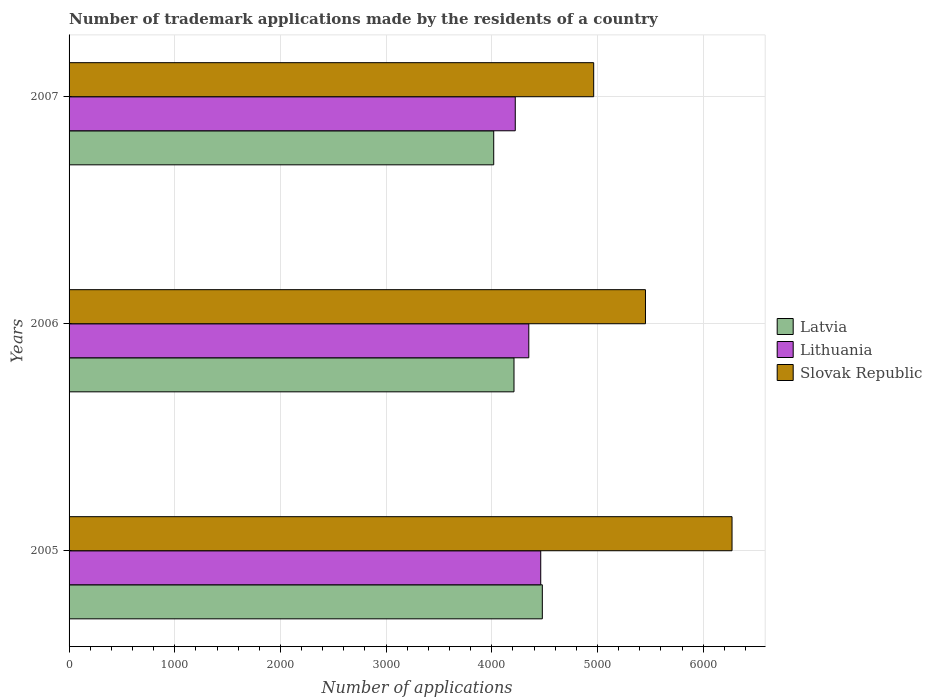Are the number of bars per tick equal to the number of legend labels?
Offer a terse response. Yes. How many bars are there on the 2nd tick from the bottom?
Provide a short and direct response. 3. What is the label of the 2nd group of bars from the top?
Offer a terse response. 2006. In how many cases, is the number of bars for a given year not equal to the number of legend labels?
Your answer should be very brief. 0. What is the number of trademark applications made by the residents in Latvia in 2006?
Make the answer very short. 4210. Across all years, what is the maximum number of trademark applications made by the residents in Latvia?
Give a very brief answer. 4478. Across all years, what is the minimum number of trademark applications made by the residents in Latvia?
Keep it short and to the point. 4018. What is the total number of trademark applications made by the residents in Lithuania in the graph?
Provide a short and direct response. 1.30e+04. What is the difference between the number of trademark applications made by the residents in Slovak Republic in 2005 and that in 2006?
Provide a short and direct response. 819. What is the difference between the number of trademark applications made by the residents in Slovak Republic in 2005 and the number of trademark applications made by the residents in Latvia in 2007?
Keep it short and to the point. 2255. What is the average number of trademark applications made by the residents in Lithuania per year?
Your answer should be compact. 4345. In the year 2005, what is the difference between the number of trademark applications made by the residents in Lithuania and number of trademark applications made by the residents in Slovak Republic?
Ensure brevity in your answer.  -1810. What is the ratio of the number of trademark applications made by the residents in Latvia in 2005 to that in 2006?
Offer a very short reply. 1.06. Is the number of trademark applications made by the residents in Latvia in 2005 less than that in 2007?
Ensure brevity in your answer.  No. Is the difference between the number of trademark applications made by the residents in Lithuania in 2005 and 2007 greater than the difference between the number of trademark applications made by the residents in Slovak Republic in 2005 and 2007?
Offer a terse response. No. What is the difference between the highest and the second highest number of trademark applications made by the residents in Lithuania?
Offer a terse response. 113. What is the difference between the highest and the lowest number of trademark applications made by the residents in Lithuania?
Make the answer very short. 241. What does the 1st bar from the top in 2005 represents?
Offer a terse response. Slovak Republic. What does the 2nd bar from the bottom in 2005 represents?
Give a very brief answer. Lithuania. How many bars are there?
Provide a short and direct response. 9. Are all the bars in the graph horizontal?
Provide a short and direct response. Yes. What is the difference between two consecutive major ticks on the X-axis?
Your answer should be very brief. 1000. Does the graph contain any zero values?
Keep it short and to the point. No. Does the graph contain grids?
Make the answer very short. Yes. How are the legend labels stacked?
Your response must be concise. Vertical. What is the title of the graph?
Your response must be concise. Number of trademark applications made by the residents of a country. What is the label or title of the X-axis?
Your response must be concise. Number of applications. What is the label or title of the Y-axis?
Ensure brevity in your answer.  Years. What is the Number of applications of Latvia in 2005?
Offer a terse response. 4478. What is the Number of applications of Lithuania in 2005?
Your response must be concise. 4463. What is the Number of applications of Slovak Republic in 2005?
Provide a succinct answer. 6273. What is the Number of applications of Latvia in 2006?
Ensure brevity in your answer.  4210. What is the Number of applications of Lithuania in 2006?
Your answer should be very brief. 4350. What is the Number of applications in Slovak Republic in 2006?
Provide a short and direct response. 5454. What is the Number of applications in Latvia in 2007?
Ensure brevity in your answer.  4018. What is the Number of applications in Lithuania in 2007?
Ensure brevity in your answer.  4222. What is the Number of applications in Slovak Republic in 2007?
Your answer should be very brief. 4964. Across all years, what is the maximum Number of applications of Latvia?
Your answer should be compact. 4478. Across all years, what is the maximum Number of applications of Lithuania?
Keep it short and to the point. 4463. Across all years, what is the maximum Number of applications of Slovak Republic?
Your answer should be compact. 6273. Across all years, what is the minimum Number of applications of Latvia?
Offer a very short reply. 4018. Across all years, what is the minimum Number of applications in Lithuania?
Give a very brief answer. 4222. Across all years, what is the minimum Number of applications of Slovak Republic?
Give a very brief answer. 4964. What is the total Number of applications in Latvia in the graph?
Offer a very short reply. 1.27e+04. What is the total Number of applications of Lithuania in the graph?
Your answer should be very brief. 1.30e+04. What is the total Number of applications of Slovak Republic in the graph?
Make the answer very short. 1.67e+04. What is the difference between the Number of applications of Latvia in 2005 and that in 2006?
Offer a very short reply. 268. What is the difference between the Number of applications of Lithuania in 2005 and that in 2006?
Offer a very short reply. 113. What is the difference between the Number of applications in Slovak Republic in 2005 and that in 2006?
Your answer should be compact. 819. What is the difference between the Number of applications in Latvia in 2005 and that in 2007?
Make the answer very short. 460. What is the difference between the Number of applications of Lithuania in 2005 and that in 2007?
Your answer should be very brief. 241. What is the difference between the Number of applications of Slovak Republic in 2005 and that in 2007?
Your answer should be very brief. 1309. What is the difference between the Number of applications in Latvia in 2006 and that in 2007?
Your response must be concise. 192. What is the difference between the Number of applications in Lithuania in 2006 and that in 2007?
Give a very brief answer. 128. What is the difference between the Number of applications in Slovak Republic in 2006 and that in 2007?
Provide a short and direct response. 490. What is the difference between the Number of applications of Latvia in 2005 and the Number of applications of Lithuania in 2006?
Offer a terse response. 128. What is the difference between the Number of applications in Latvia in 2005 and the Number of applications in Slovak Republic in 2006?
Make the answer very short. -976. What is the difference between the Number of applications of Lithuania in 2005 and the Number of applications of Slovak Republic in 2006?
Ensure brevity in your answer.  -991. What is the difference between the Number of applications of Latvia in 2005 and the Number of applications of Lithuania in 2007?
Make the answer very short. 256. What is the difference between the Number of applications of Latvia in 2005 and the Number of applications of Slovak Republic in 2007?
Provide a short and direct response. -486. What is the difference between the Number of applications of Lithuania in 2005 and the Number of applications of Slovak Republic in 2007?
Make the answer very short. -501. What is the difference between the Number of applications in Latvia in 2006 and the Number of applications in Lithuania in 2007?
Make the answer very short. -12. What is the difference between the Number of applications of Latvia in 2006 and the Number of applications of Slovak Republic in 2007?
Keep it short and to the point. -754. What is the difference between the Number of applications in Lithuania in 2006 and the Number of applications in Slovak Republic in 2007?
Provide a succinct answer. -614. What is the average Number of applications in Latvia per year?
Make the answer very short. 4235.33. What is the average Number of applications in Lithuania per year?
Give a very brief answer. 4345. What is the average Number of applications in Slovak Republic per year?
Your response must be concise. 5563.67. In the year 2005, what is the difference between the Number of applications in Latvia and Number of applications in Lithuania?
Your response must be concise. 15. In the year 2005, what is the difference between the Number of applications of Latvia and Number of applications of Slovak Republic?
Provide a short and direct response. -1795. In the year 2005, what is the difference between the Number of applications in Lithuania and Number of applications in Slovak Republic?
Provide a short and direct response. -1810. In the year 2006, what is the difference between the Number of applications in Latvia and Number of applications in Lithuania?
Your answer should be very brief. -140. In the year 2006, what is the difference between the Number of applications of Latvia and Number of applications of Slovak Republic?
Keep it short and to the point. -1244. In the year 2006, what is the difference between the Number of applications in Lithuania and Number of applications in Slovak Republic?
Ensure brevity in your answer.  -1104. In the year 2007, what is the difference between the Number of applications in Latvia and Number of applications in Lithuania?
Your response must be concise. -204. In the year 2007, what is the difference between the Number of applications in Latvia and Number of applications in Slovak Republic?
Make the answer very short. -946. In the year 2007, what is the difference between the Number of applications of Lithuania and Number of applications of Slovak Republic?
Your answer should be very brief. -742. What is the ratio of the Number of applications in Latvia in 2005 to that in 2006?
Make the answer very short. 1.06. What is the ratio of the Number of applications in Lithuania in 2005 to that in 2006?
Keep it short and to the point. 1.03. What is the ratio of the Number of applications of Slovak Republic in 2005 to that in 2006?
Keep it short and to the point. 1.15. What is the ratio of the Number of applications in Latvia in 2005 to that in 2007?
Provide a succinct answer. 1.11. What is the ratio of the Number of applications in Lithuania in 2005 to that in 2007?
Offer a very short reply. 1.06. What is the ratio of the Number of applications of Slovak Republic in 2005 to that in 2007?
Keep it short and to the point. 1.26. What is the ratio of the Number of applications of Latvia in 2006 to that in 2007?
Give a very brief answer. 1.05. What is the ratio of the Number of applications in Lithuania in 2006 to that in 2007?
Provide a succinct answer. 1.03. What is the ratio of the Number of applications of Slovak Republic in 2006 to that in 2007?
Your answer should be very brief. 1.1. What is the difference between the highest and the second highest Number of applications in Latvia?
Ensure brevity in your answer.  268. What is the difference between the highest and the second highest Number of applications of Lithuania?
Your answer should be very brief. 113. What is the difference between the highest and the second highest Number of applications in Slovak Republic?
Give a very brief answer. 819. What is the difference between the highest and the lowest Number of applications of Latvia?
Give a very brief answer. 460. What is the difference between the highest and the lowest Number of applications in Lithuania?
Your answer should be very brief. 241. What is the difference between the highest and the lowest Number of applications in Slovak Republic?
Your response must be concise. 1309. 